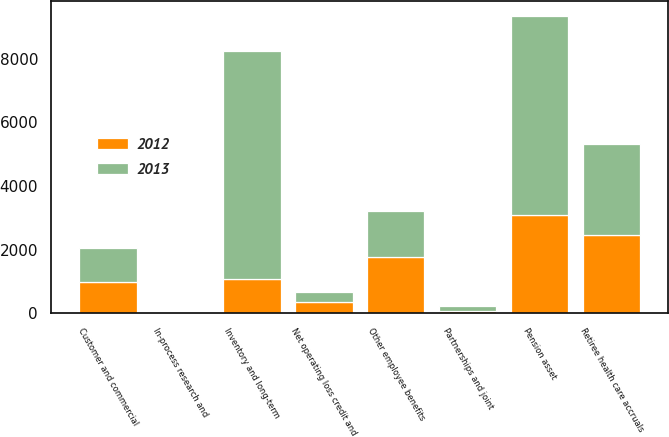Convert chart to OTSL. <chart><loc_0><loc_0><loc_500><loc_500><stacked_bar_chart><ecel><fcel>Retiree health care accruals<fcel>Inventory and long-term<fcel>Partnerships and joint<fcel>Other employee benefits<fcel>In-process research and<fcel>Net operating loss credit and<fcel>Pension asset<fcel>Customer and commercial<nl><fcel>2012<fcel>2458<fcel>1078<fcel>62<fcel>1773<fcel>23<fcel>362<fcel>3099<fcel>990<nl><fcel>2013<fcel>2867<fcel>7151<fcel>162<fcel>1427<fcel>37<fcel>307<fcel>6232<fcel>1078<nl></chart> 